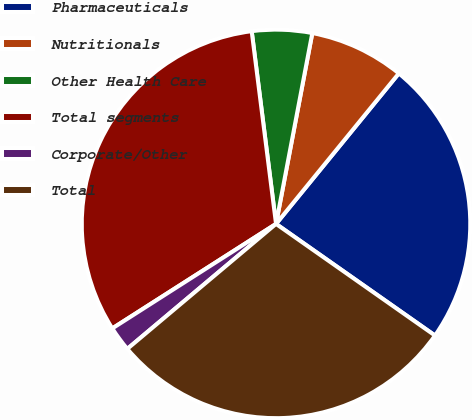<chart> <loc_0><loc_0><loc_500><loc_500><pie_chart><fcel>Pharmaceuticals<fcel>Nutritionals<fcel>Other Health Care<fcel>Total segments<fcel>Corporate/Other<fcel>Total<nl><fcel>23.85%<fcel>7.9%<fcel>4.99%<fcel>32.04%<fcel>2.08%<fcel>29.13%<nl></chart> 